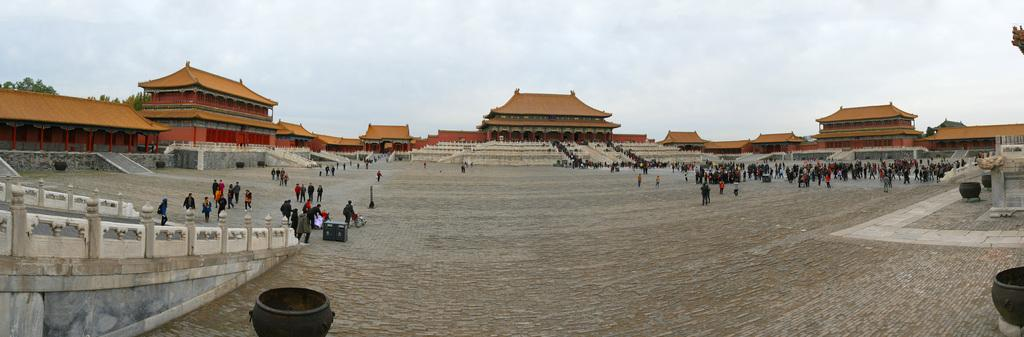What are the people in the image doing? The people in the image are on a path. What structures can be seen in the image? There are posts and railings in the image. What can be seen in the background of the image? There are houses, buildings, railings, and people in the background of the image. The sky is also visible in the background. What type of bed can be seen in the image? There is no bed present in the image. Is there a rainstorm happening in the image? There is no indication of a rainstorm in the image; the sky is visible, but it does not appear to be stormy. 